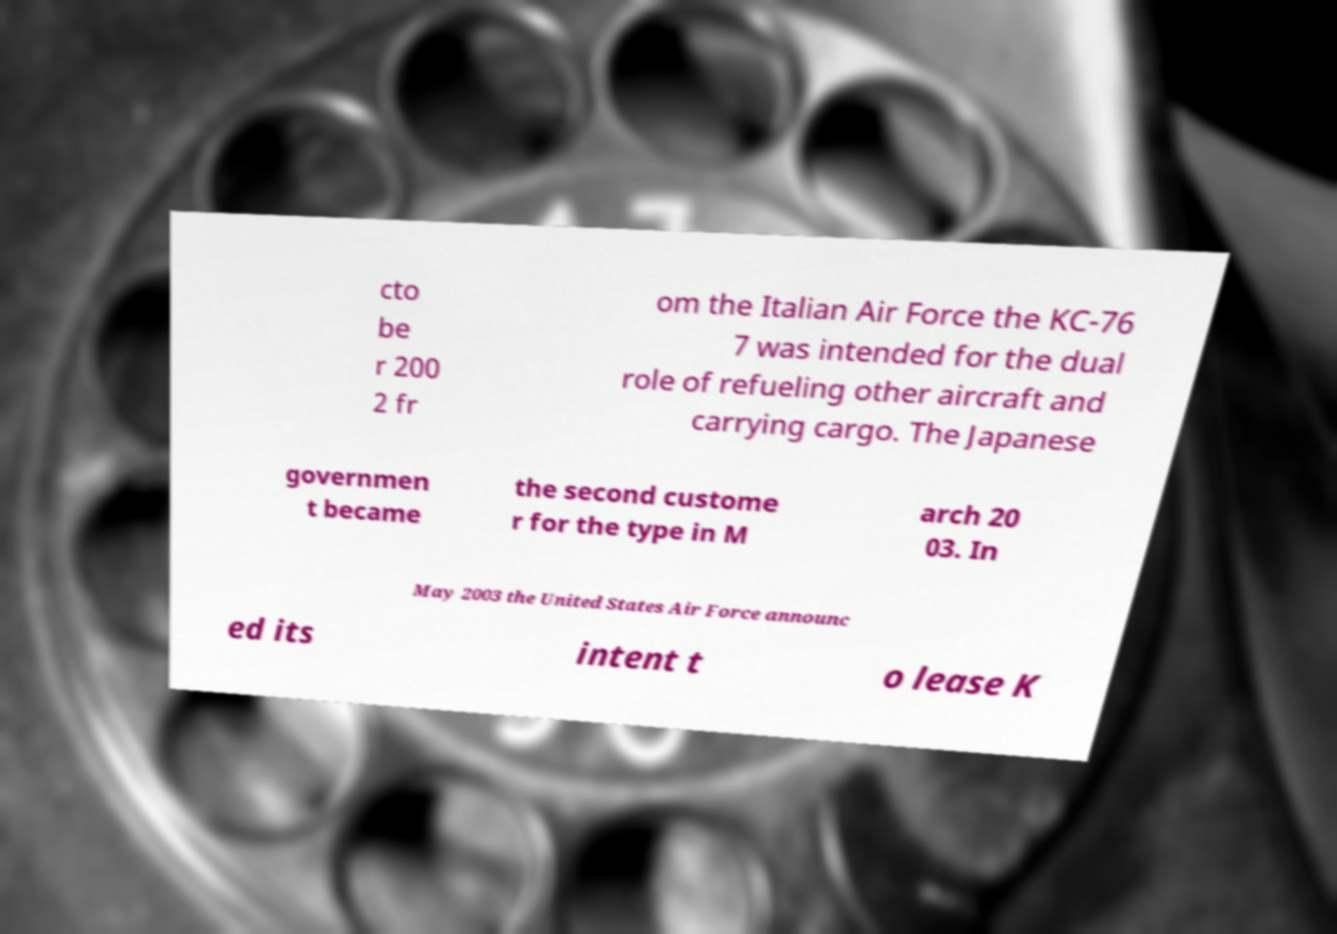Could you assist in decoding the text presented in this image and type it out clearly? cto be r 200 2 fr om the Italian Air Force the KC-76 7 was intended for the dual role of refueling other aircraft and carrying cargo. The Japanese governmen t became the second custome r for the type in M arch 20 03. In May 2003 the United States Air Force announc ed its intent t o lease K 